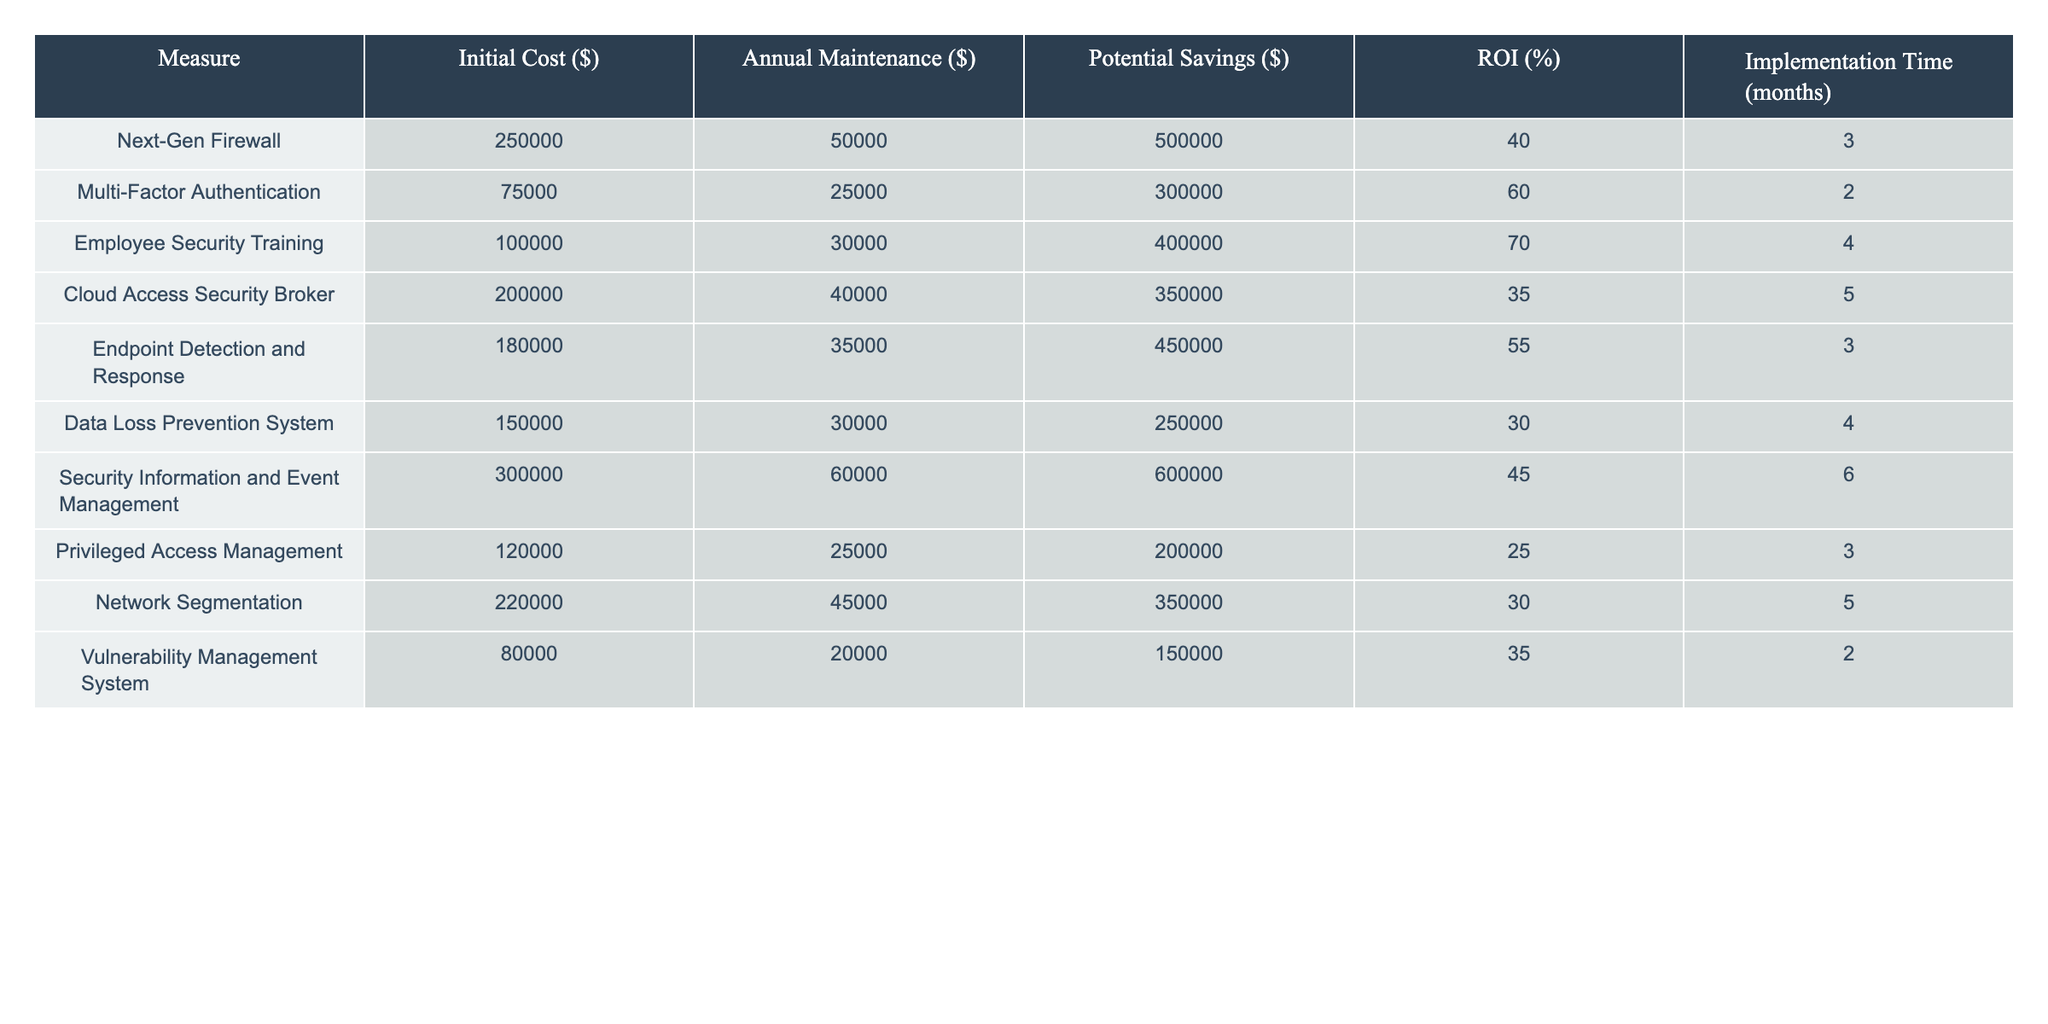What is the initial cost of implementing Multi-Factor Authentication? The table clearly lists Multi-Factor Authentication under the "Measure" column. The corresponding "Initial Cost" value is found in the same row, which is 75,000 dollars.
Answer: 75,000 Which cybersecurity measure has the highest potential savings? To find the measure with the highest potential savings, I look at the "Potential Savings" column and compare the values. The maximum value is 600,000 dollars for the Security Information and Event Management measure.
Answer: Security Information and Event Management What is the average annual maintenance cost of all measures? First, I sum the annual maintenance costs: 50,000 + 25,000 + 30,000 + 40,000 + 35,000 + 30,000 + 60,000 + 25,000 + 45,000 + 20,000 =  390,000 dollars. There are 10 measures, so I divide 390,000 by 10 to get the average, which is 39,000 dollars.
Answer: 39,000 Is the ROI for the Data Loss Prevention System greater than the ROI for the Endpoint Detection and Response? The ROI for the Data Loss Prevention System is 30 percent, while the ROI for Endpoint Detection and Response is 55 percent. Since 30 is less than 55, the answer is no.
Answer: No Which measure has the shortest implementation time and what is that time? I look at the "Implementation Time" column to find the shortest value. The smallest number is 2 months, which applies to both Multi-Factor Authentication and Vulnerability Management System. Thus, the shortest time is 2 months for these measures.
Answer: 2 months 